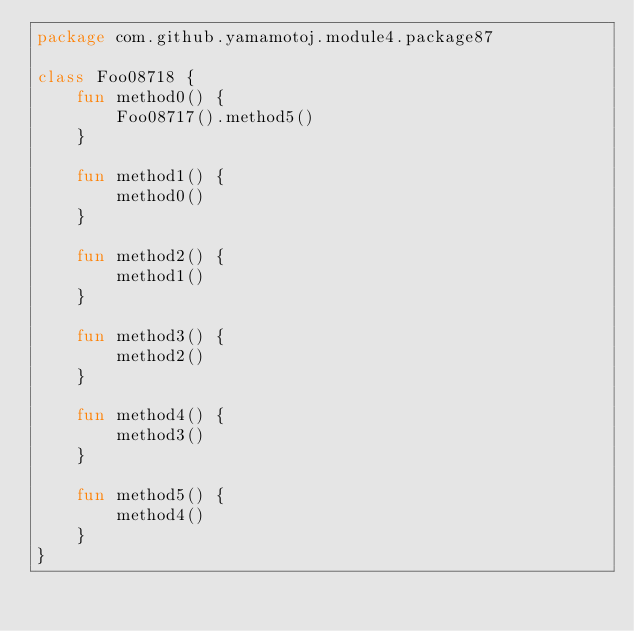Convert code to text. <code><loc_0><loc_0><loc_500><loc_500><_Kotlin_>package com.github.yamamotoj.module4.package87

class Foo08718 {
    fun method0() {
        Foo08717().method5()
    }

    fun method1() {
        method0()
    }

    fun method2() {
        method1()
    }

    fun method3() {
        method2()
    }

    fun method4() {
        method3()
    }

    fun method5() {
        method4()
    }
}
</code> 